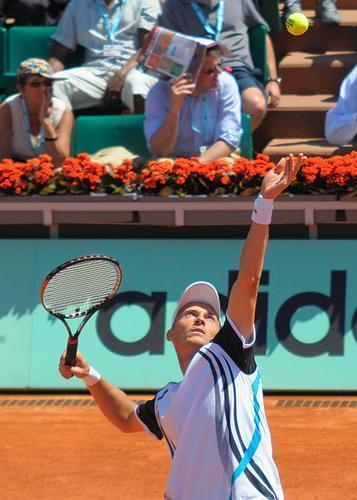How many tennis rackets are there?
Give a very brief answer. 1. How many people are there?
Give a very brief answer. 5. How many chairs can you see?
Give a very brief answer. 2. 